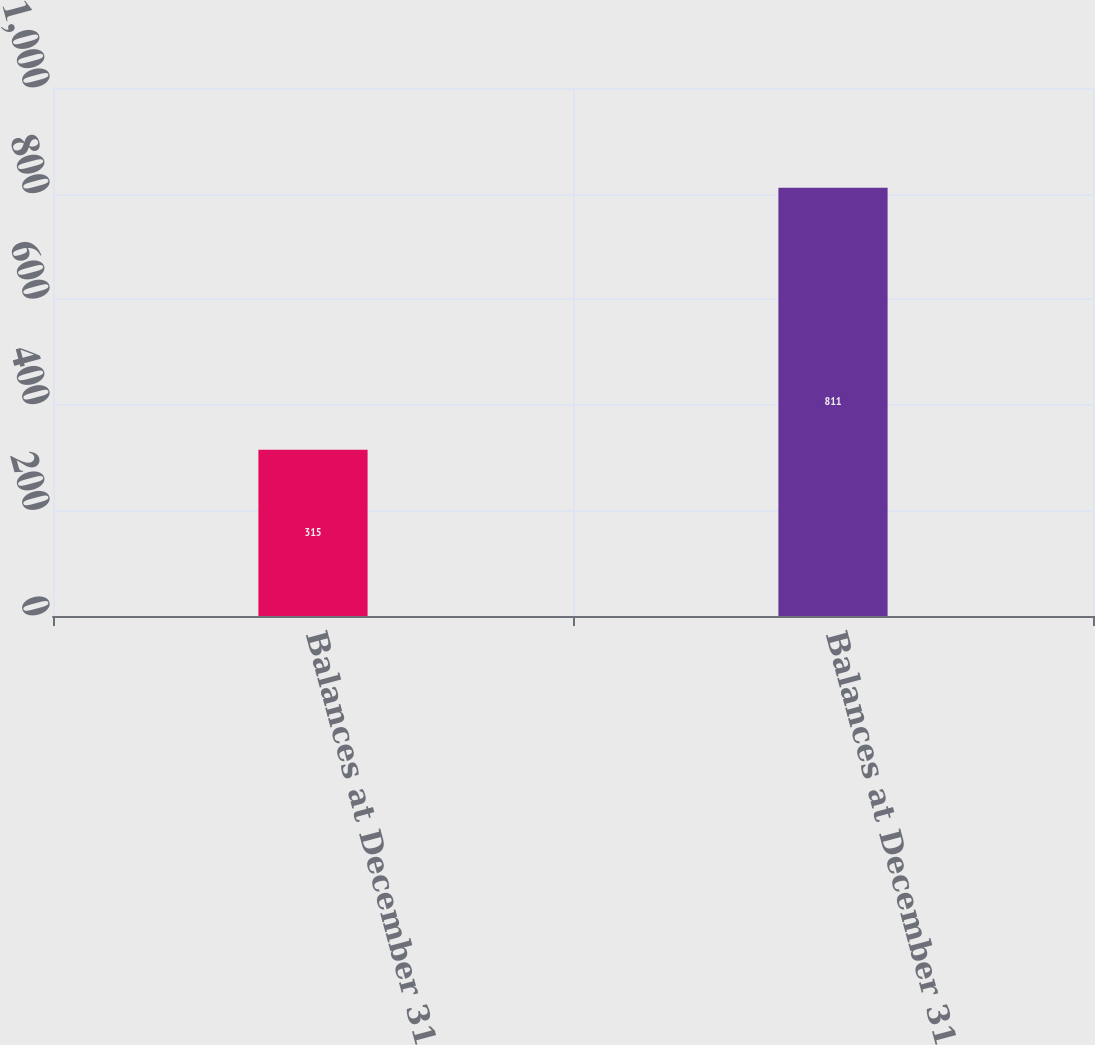<chart> <loc_0><loc_0><loc_500><loc_500><bar_chart><fcel>Balances at December 31 2009<fcel>Balances at December 31 2011<nl><fcel>315<fcel>811<nl></chart> 